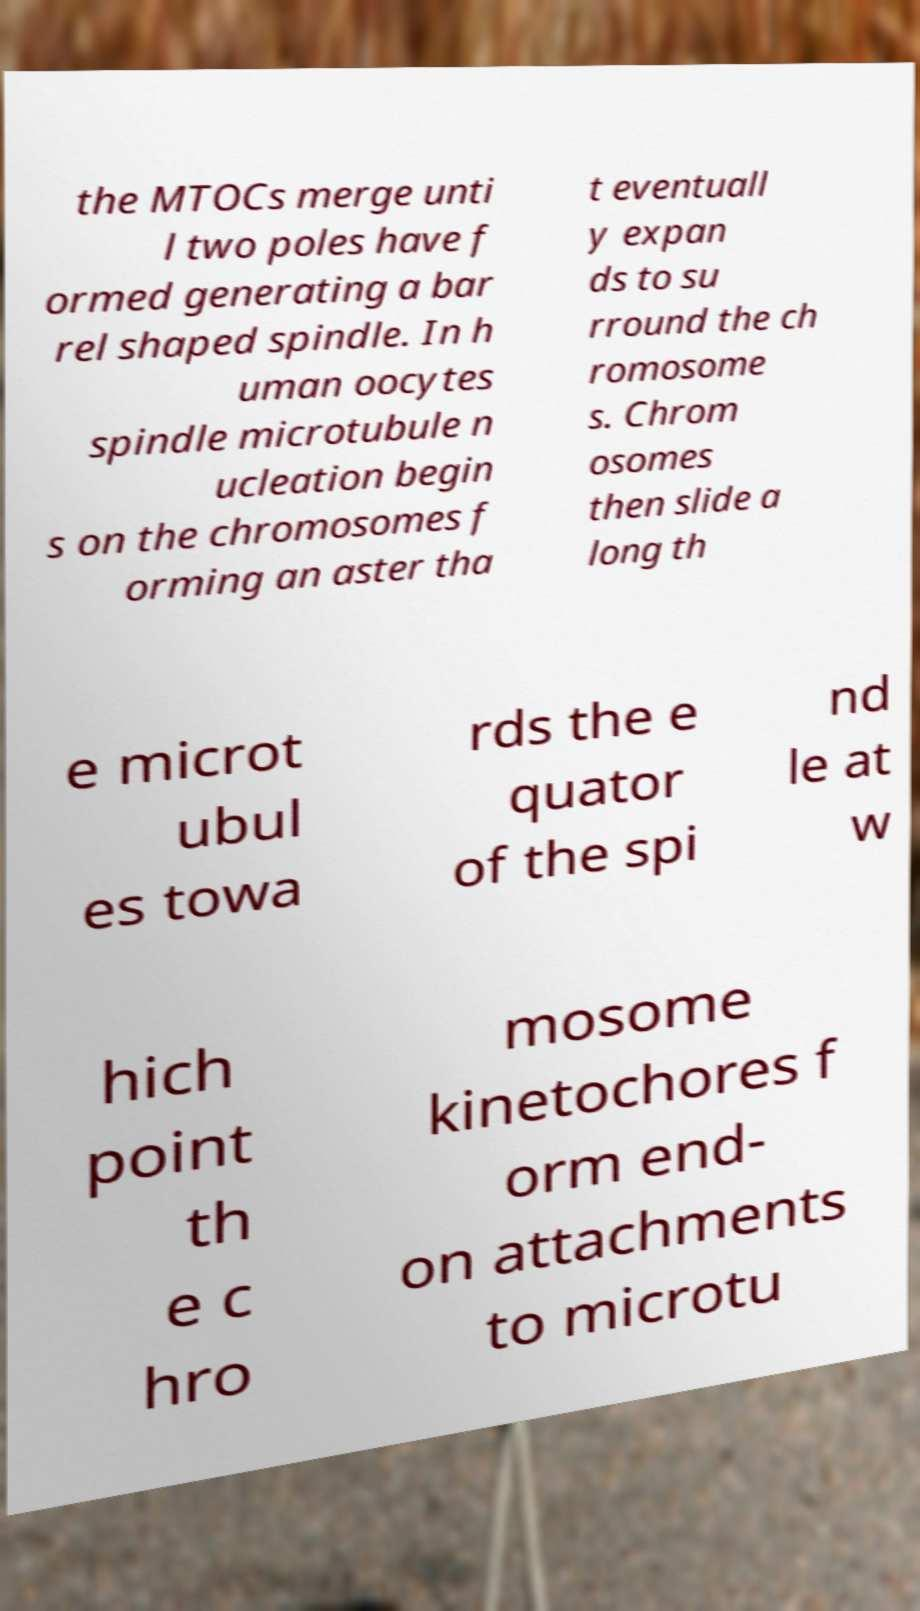There's text embedded in this image that I need extracted. Can you transcribe it verbatim? the MTOCs merge unti l two poles have f ormed generating a bar rel shaped spindle. In h uman oocytes spindle microtubule n ucleation begin s on the chromosomes f orming an aster tha t eventuall y expan ds to su rround the ch romosome s. Chrom osomes then slide a long th e microt ubul es towa rds the e quator of the spi nd le at w hich point th e c hro mosome kinetochores f orm end- on attachments to microtu 